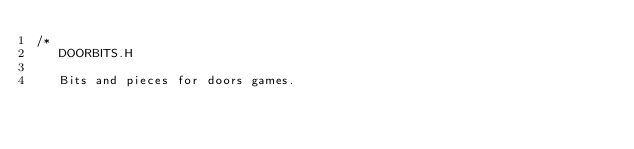Convert code to text. <code><loc_0><loc_0><loc_500><loc_500><_C_>/*
   DOORBITS.H

   Bits and pieces for doors games.</code> 